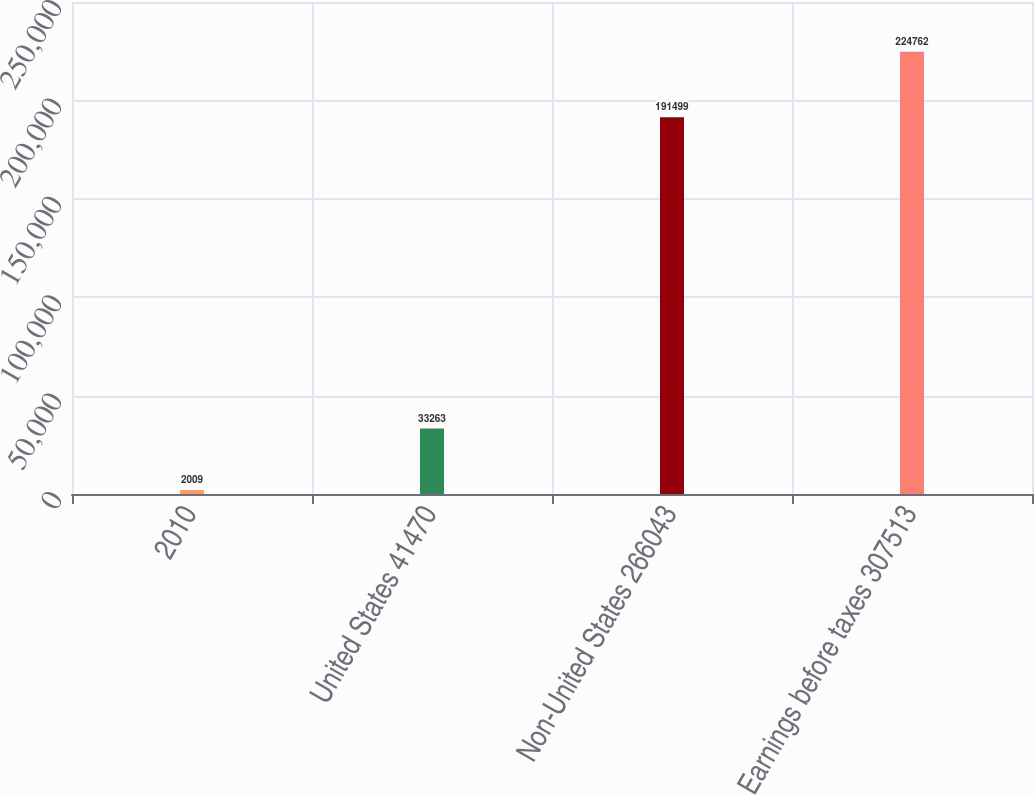Convert chart. <chart><loc_0><loc_0><loc_500><loc_500><bar_chart><fcel>2010<fcel>United States 41470<fcel>Non-United States 266043<fcel>Earnings before taxes 307513<nl><fcel>2009<fcel>33263<fcel>191499<fcel>224762<nl></chart> 